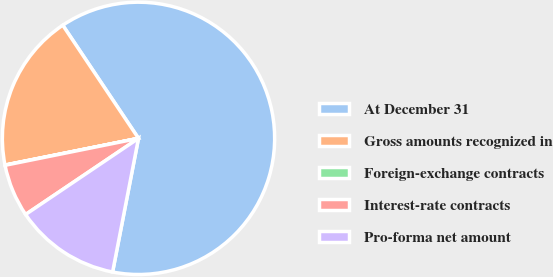Convert chart. <chart><loc_0><loc_0><loc_500><loc_500><pie_chart><fcel>At December 31<fcel>Gross amounts recognized in<fcel>Foreign-exchange contracts<fcel>Interest-rate contracts<fcel>Pro-forma net amount<nl><fcel>62.43%<fcel>18.75%<fcel>0.03%<fcel>6.27%<fcel>12.51%<nl></chart> 